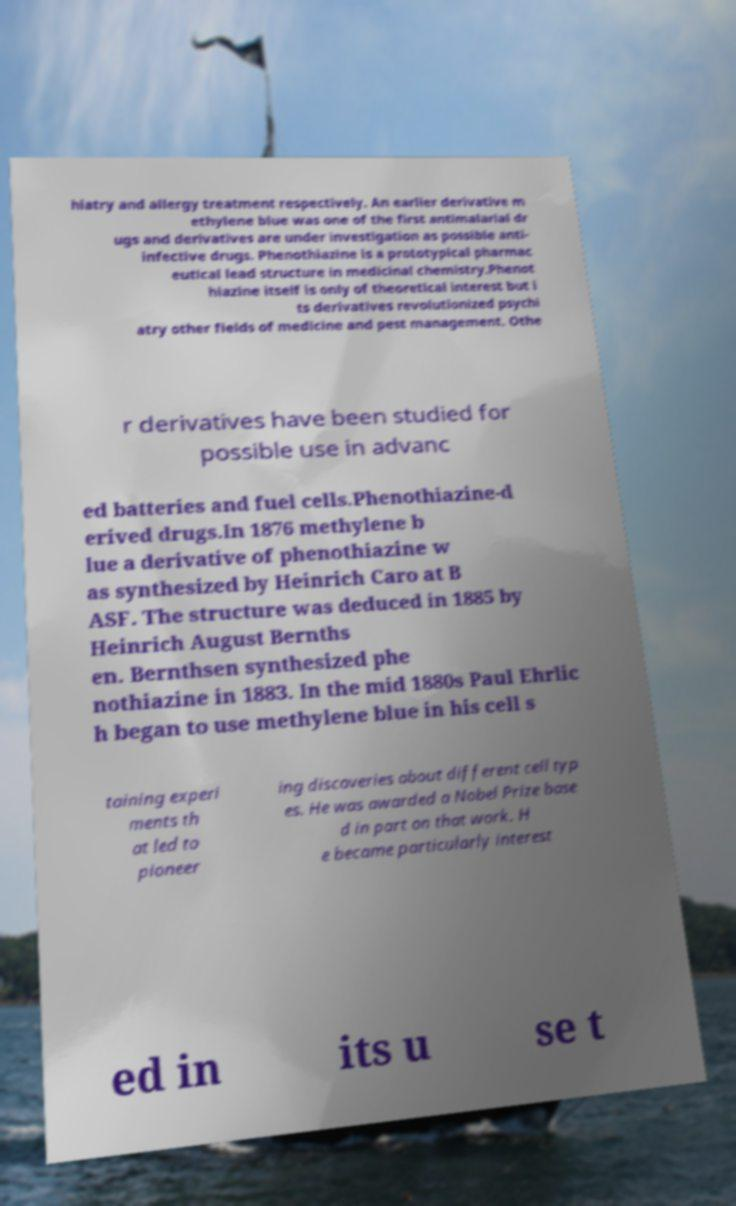Please identify and transcribe the text found in this image. hiatry and allergy treatment respectively. An earlier derivative m ethylene blue was one of the first antimalarial dr ugs and derivatives are under investigation as possible anti- infective drugs. Phenothiazine is a prototypical pharmac eutical lead structure in medicinal chemistry.Phenot hiazine itself is only of theoretical interest but i ts derivatives revolutionized psychi atry other fields of medicine and pest management. Othe r derivatives have been studied for possible use in advanc ed batteries and fuel cells.Phenothiazine-d erived drugs.In 1876 methylene b lue a derivative of phenothiazine w as synthesized by Heinrich Caro at B ASF. The structure was deduced in 1885 by Heinrich August Bernths en. Bernthsen synthesized phe nothiazine in 1883. In the mid 1880s Paul Ehrlic h began to use methylene blue in his cell s taining experi ments th at led to pioneer ing discoveries about different cell typ es. He was awarded a Nobel Prize base d in part on that work. H e became particularly interest ed in its u se t 